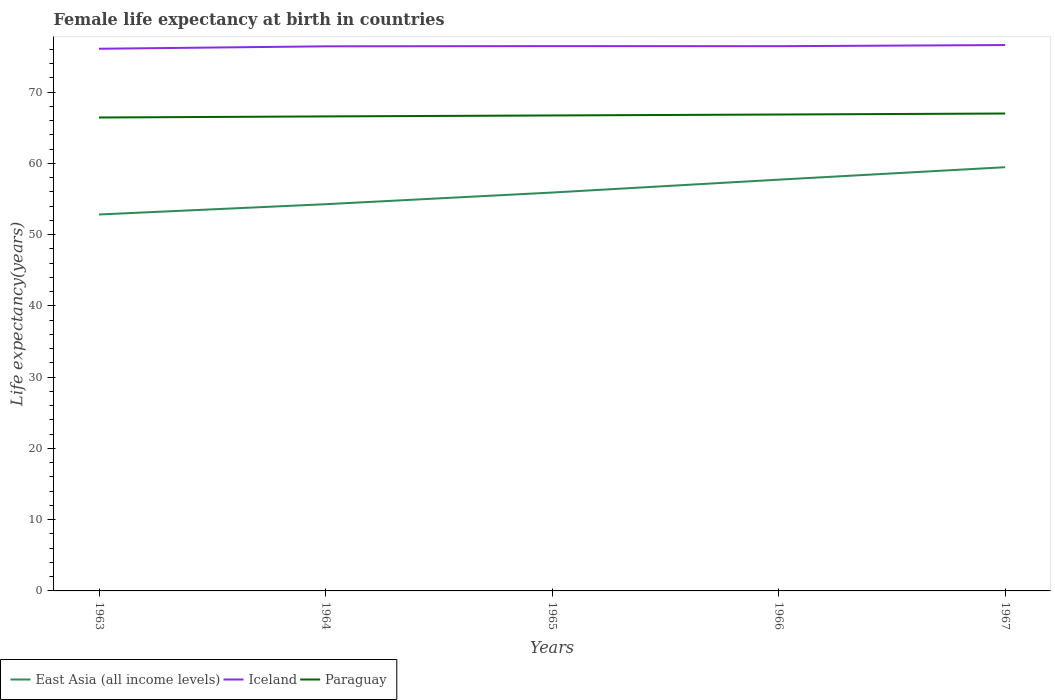How many different coloured lines are there?
Your answer should be compact. 3. Does the line corresponding to Paraguay intersect with the line corresponding to East Asia (all income levels)?
Offer a terse response. No. Is the number of lines equal to the number of legend labels?
Provide a short and direct response. Yes. Across all years, what is the maximum female life expectancy at birth in Iceland?
Offer a very short reply. 76.07. In which year was the female life expectancy at birth in East Asia (all income levels) maximum?
Keep it short and to the point. 1963. What is the total female life expectancy at birth in Paraguay in the graph?
Your answer should be compact. -0.14. What is the difference between the highest and the second highest female life expectancy at birth in East Asia (all income levels)?
Provide a short and direct response. 6.63. Is the female life expectancy at birth in Paraguay strictly greater than the female life expectancy at birth in East Asia (all income levels) over the years?
Offer a very short reply. No. Are the values on the major ticks of Y-axis written in scientific E-notation?
Your answer should be very brief. No. Does the graph contain any zero values?
Provide a short and direct response. No. Does the graph contain grids?
Provide a short and direct response. No. How are the legend labels stacked?
Offer a very short reply. Horizontal. What is the title of the graph?
Offer a very short reply. Female life expectancy at birth in countries. What is the label or title of the Y-axis?
Provide a short and direct response. Life expectancy(years). What is the Life expectancy(years) in East Asia (all income levels) in 1963?
Your answer should be very brief. 52.82. What is the Life expectancy(years) in Iceland in 1963?
Offer a very short reply. 76.07. What is the Life expectancy(years) of Paraguay in 1963?
Keep it short and to the point. 66.42. What is the Life expectancy(years) in East Asia (all income levels) in 1964?
Provide a succinct answer. 54.26. What is the Life expectancy(years) in Iceland in 1964?
Provide a succinct answer. 76.41. What is the Life expectancy(years) of Paraguay in 1964?
Offer a very short reply. 66.58. What is the Life expectancy(years) in East Asia (all income levels) in 1965?
Ensure brevity in your answer.  55.89. What is the Life expectancy(years) in Iceland in 1965?
Your answer should be compact. 76.44. What is the Life expectancy(years) in Paraguay in 1965?
Offer a very short reply. 66.71. What is the Life expectancy(years) of East Asia (all income levels) in 1966?
Keep it short and to the point. 57.7. What is the Life expectancy(years) in Iceland in 1966?
Ensure brevity in your answer.  76.43. What is the Life expectancy(years) of Paraguay in 1966?
Your response must be concise. 66.84. What is the Life expectancy(years) of East Asia (all income levels) in 1967?
Provide a short and direct response. 59.45. What is the Life expectancy(years) of Iceland in 1967?
Give a very brief answer. 76.59. What is the Life expectancy(years) of Paraguay in 1967?
Ensure brevity in your answer.  66.98. Across all years, what is the maximum Life expectancy(years) in East Asia (all income levels)?
Give a very brief answer. 59.45. Across all years, what is the maximum Life expectancy(years) in Iceland?
Ensure brevity in your answer.  76.59. Across all years, what is the maximum Life expectancy(years) of Paraguay?
Your answer should be very brief. 66.98. Across all years, what is the minimum Life expectancy(years) in East Asia (all income levels)?
Make the answer very short. 52.82. Across all years, what is the minimum Life expectancy(years) in Iceland?
Provide a succinct answer. 76.07. Across all years, what is the minimum Life expectancy(years) in Paraguay?
Ensure brevity in your answer.  66.42. What is the total Life expectancy(years) in East Asia (all income levels) in the graph?
Your answer should be very brief. 280.12. What is the total Life expectancy(years) in Iceland in the graph?
Make the answer very short. 381.94. What is the total Life expectancy(years) of Paraguay in the graph?
Give a very brief answer. 333.54. What is the difference between the Life expectancy(years) of East Asia (all income levels) in 1963 and that in 1964?
Your answer should be compact. -1.44. What is the difference between the Life expectancy(years) of Iceland in 1963 and that in 1964?
Your response must be concise. -0.34. What is the difference between the Life expectancy(years) in Paraguay in 1963 and that in 1964?
Your answer should be very brief. -0.15. What is the difference between the Life expectancy(years) in East Asia (all income levels) in 1963 and that in 1965?
Provide a short and direct response. -3.08. What is the difference between the Life expectancy(years) of Iceland in 1963 and that in 1965?
Ensure brevity in your answer.  -0.37. What is the difference between the Life expectancy(years) of Paraguay in 1963 and that in 1965?
Offer a terse response. -0.29. What is the difference between the Life expectancy(years) of East Asia (all income levels) in 1963 and that in 1966?
Your answer should be very brief. -4.89. What is the difference between the Life expectancy(years) in Iceland in 1963 and that in 1966?
Make the answer very short. -0.36. What is the difference between the Life expectancy(years) of Paraguay in 1963 and that in 1966?
Give a very brief answer. -0.42. What is the difference between the Life expectancy(years) in East Asia (all income levels) in 1963 and that in 1967?
Make the answer very short. -6.63. What is the difference between the Life expectancy(years) in Iceland in 1963 and that in 1967?
Your answer should be compact. -0.52. What is the difference between the Life expectancy(years) of Paraguay in 1963 and that in 1967?
Give a very brief answer. -0.56. What is the difference between the Life expectancy(years) in East Asia (all income levels) in 1964 and that in 1965?
Provide a short and direct response. -1.64. What is the difference between the Life expectancy(years) in Iceland in 1964 and that in 1965?
Make the answer very short. -0.03. What is the difference between the Life expectancy(years) of Paraguay in 1964 and that in 1965?
Offer a terse response. -0.13. What is the difference between the Life expectancy(years) in East Asia (all income levels) in 1964 and that in 1966?
Offer a very short reply. -3.44. What is the difference between the Life expectancy(years) in Iceland in 1964 and that in 1966?
Your answer should be compact. -0.02. What is the difference between the Life expectancy(years) of Paraguay in 1964 and that in 1966?
Keep it short and to the point. -0.27. What is the difference between the Life expectancy(years) of East Asia (all income levels) in 1964 and that in 1967?
Provide a succinct answer. -5.19. What is the difference between the Life expectancy(years) in Iceland in 1964 and that in 1967?
Your answer should be very brief. -0.18. What is the difference between the Life expectancy(years) of Paraguay in 1964 and that in 1967?
Your answer should be compact. -0.41. What is the difference between the Life expectancy(years) in East Asia (all income levels) in 1965 and that in 1966?
Keep it short and to the point. -1.81. What is the difference between the Life expectancy(years) of Iceland in 1965 and that in 1966?
Offer a very short reply. 0.01. What is the difference between the Life expectancy(years) in Paraguay in 1965 and that in 1966?
Offer a very short reply. -0.13. What is the difference between the Life expectancy(years) of East Asia (all income levels) in 1965 and that in 1967?
Ensure brevity in your answer.  -3.56. What is the difference between the Life expectancy(years) of Paraguay in 1965 and that in 1967?
Offer a very short reply. -0.27. What is the difference between the Life expectancy(years) of East Asia (all income levels) in 1966 and that in 1967?
Offer a terse response. -1.75. What is the difference between the Life expectancy(years) of Iceland in 1966 and that in 1967?
Ensure brevity in your answer.  -0.16. What is the difference between the Life expectancy(years) of Paraguay in 1966 and that in 1967?
Your answer should be compact. -0.14. What is the difference between the Life expectancy(years) of East Asia (all income levels) in 1963 and the Life expectancy(years) of Iceland in 1964?
Your response must be concise. -23.59. What is the difference between the Life expectancy(years) in East Asia (all income levels) in 1963 and the Life expectancy(years) in Paraguay in 1964?
Offer a very short reply. -13.76. What is the difference between the Life expectancy(years) in Iceland in 1963 and the Life expectancy(years) in Paraguay in 1964?
Give a very brief answer. 9.49. What is the difference between the Life expectancy(years) in East Asia (all income levels) in 1963 and the Life expectancy(years) in Iceland in 1965?
Keep it short and to the point. -23.62. What is the difference between the Life expectancy(years) of East Asia (all income levels) in 1963 and the Life expectancy(years) of Paraguay in 1965?
Ensure brevity in your answer.  -13.89. What is the difference between the Life expectancy(years) of Iceland in 1963 and the Life expectancy(years) of Paraguay in 1965?
Your answer should be compact. 9.36. What is the difference between the Life expectancy(years) of East Asia (all income levels) in 1963 and the Life expectancy(years) of Iceland in 1966?
Give a very brief answer. -23.61. What is the difference between the Life expectancy(years) of East Asia (all income levels) in 1963 and the Life expectancy(years) of Paraguay in 1966?
Offer a terse response. -14.03. What is the difference between the Life expectancy(years) in Iceland in 1963 and the Life expectancy(years) in Paraguay in 1966?
Your answer should be compact. 9.23. What is the difference between the Life expectancy(years) in East Asia (all income levels) in 1963 and the Life expectancy(years) in Iceland in 1967?
Your answer should be very brief. -23.77. What is the difference between the Life expectancy(years) of East Asia (all income levels) in 1963 and the Life expectancy(years) of Paraguay in 1967?
Your response must be concise. -14.17. What is the difference between the Life expectancy(years) of Iceland in 1963 and the Life expectancy(years) of Paraguay in 1967?
Make the answer very short. 9.09. What is the difference between the Life expectancy(years) in East Asia (all income levels) in 1964 and the Life expectancy(years) in Iceland in 1965?
Give a very brief answer. -22.18. What is the difference between the Life expectancy(years) in East Asia (all income levels) in 1964 and the Life expectancy(years) in Paraguay in 1965?
Offer a terse response. -12.45. What is the difference between the Life expectancy(years) in Iceland in 1964 and the Life expectancy(years) in Paraguay in 1965?
Provide a short and direct response. 9.7. What is the difference between the Life expectancy(years) in East Asia (all income levels) in 1964 and the Life expectancy(years) in Iceland in 1966?
Ensure brevity in your answer.  -22.17. What is the difference between the Life expectancy(years) of East Asia (all income levels) in 1964 and the Life expectancy(years) of Paraguay in 1966?
Offer a terse response. -12.58. What is the difference between the Life expectancy(years) of Iceland in 1964 and the Life expectancy(years) of Paraguay in 1966?
Give a very brief answer. 9.57. What is the difference between the Life expectancy(years) of East Asia (all income levels) in 1964 and the Life expectancy(years) of Iceland in 1967?
Your answer should be compact. -22.33. What is the difference between the Life expectancy(years) of East Asia (all income levels) in 1964 and the Life expectancy(years) of Paraguay in 1967?
Provide a short and direct response. -12.73. What is the difference between the Life expectancy(years) of Iceland in 1964 and the Life expectancy(years) of Paraguay in 1967?
Your answer should be very brief. 9.43. What is the difference between the Life expectancy(years) of East Asia (all income levels) in 1965 and the Life expectancy(years) of Iceland in 1966?
Offer a very short reply. -20.54. What is the difference between the Life expectancy(years) in East Asia (all income levels) in 1965 and the Life expectancy(years) in Paraguay in 1966?
Provide a succinct answer. -10.95. What is the difference between the Life expectancy(years) in Iceland in 1965 and the Life expectancy(years) in Paraguay in 1966?
Provide a succinct answer. 9.6. What is the difference between the Life expectancy(years) in East Asia (all income levels) in 1965 and the Life expectancy(years) in Iceland in 1967?
Give a very brief answer. -20.7. What is the difference between the Life expectancy(years) of East Asia (all income levels) in 1965 and the Life expectancy(years) of Paraguay in 1967?
Keep it short and to the point. -11.09. What is the difference between the Life expectancy(years) of Iceland in 1965 and the Life expectancy(years) of Paraguay in 1967?
Provide a succinct answer. 9.46. What is the difference between the Life expectancy(years) of East Asia (all income levels) in 1966 and the Life expectancy(years) of Iceland in 1967?
Provide a short and direct response. -18.89. What is the difference between the Life expectancy(years) in East Asia (all income levels) in 1966 and the Life expectancy(years) in Paraguay in 1967?
Provide a short and direct response. -9.28. What is the difference between the Life expectancy(years) in Iceland in 1966 and the Life expectancy(years) in Paraguay in 1967?
Offer a very short reply. 9.45. What is the average Life expectancy(years) of East Asia (all income levels) per year?
Your answer should be compact. 56.02. What is the average Life expectancy(years) in Iceland per year?
Make the answer very short. 76.39. What is the average Life expectancy(years) in Paraguay per year?
Your answer should be very brief. 66.71. In the year 1963, what is the difference between the Life expectancy(years) of East Asia (all income levels) and Life expectancy(years) of Iceland?
Provide a succinct answer. -23.25. In the year 1963, what is the difference between the Life expectancy(years) of East Asia (all income levels) and Life expectancy(years) of Paraguay?
Provide a succinct answer. -13.61. In the year 1963, what is the difference between the Life expectancy(years) of Iceland and Life expectancy(years) of Paraguay?
Ensure brevity in your answer.  9.64. In the year 1964, what is the difference between the Life expectancy(years) of East Asia (all income levels) and Life expectancy(years) of Iceland?
Give a very brief answer. -22.15. In the year 1964, what is the difference between the Life expectancy(years) in East Asia (all income levels) and Life expectancy(years) in Paraguay?
Give a very brief answer. -12.32. In the year 1964, what is the difference between the Life expectancy(years) in Iceland and Life expectancy(years) in Paraguay?
Provide a short and direct response. 9.83. In the year 1965, what is the difference between the Life expectancy(years) of East Asia (all income levels) and Life expectancy(years) of Iceland?
Ensure brevity in your answer.  -20.55. In the year 1965, what is the difference between the Life expectancy(years) of East Asia (all income levels) and Life expectancy(years) of Paraguay?
Provide a succinct answer. -10.82. In the year 1965, what is the difference between the Life expectancy(years) of Iceland and Life expectancy(years) of Paraguay?
Keep it short and to the point. 9.73. In the year 1966, what is the difference between the Life expectancy(years) of East Asia (all income levels) and Life expectancy(years) of Iceland?
Provide a short and direct response. -18.73. In the year 1966, what is the difference between the Life expectancy(years) of East Asia (all income levels) and Life expectancy(years) of Paraguay?
Your answer should be compact. -9.14. In the year 1966, what is the difference between the Life expectancy(years) of Iceland and Life expectancy(years) of Paraguay?
Keep it short and to the point. 9.59. In the year 1967, what is the difference between the Life expectancy(years) in East Asia (all income levels) and Life expectancy(years) in Iceland?
Give a very brief answer. -17.14. In the year 1967, what is the difference between the Life expectancy(years) in East Asia (all income levels) and Life expectancy(years) in Paraguay?
Offer a very short reply. -7.53. In the year 1967, what is the difference between the Life expectancy(years) in Iceland and Life expectancy(years) in Paraguay?
Give a very brief answer. 9.61. What is the ratio of the Life expectancy(years) in East Asia (all income levels) in 1963 to that in 1964?
Offer a very short reply. 0.97. What is the ratio of the Life expectancy(years) of East Asia (all income levels) in 1963 to that in 1965?
Give a very brief answer. 0.94. What is the ratio of the Life expectancy(years) of East Asia (all income levels) in 1963 to that in 1966?
Make the answer very short. 0.92. What is the ratio of the Life expectancy(years) of Iceland in 1963 to that in 1966?
Give a very brief answer. 1. What is the ratio of the Life expectancy(years) in Paraguay in 1963 to that in 1966?
Provide a short and direct response. 0.99. What is the ratio of the Life expectancy(years) of East Asia (all income levels) in 1963 to that in 1967?
Offer a very short reply. 0.89. What is the ratio of the Life expectancy(years) in East Asia (all income levels) in 1964 to that in 1965?
Ensure brevity in your answer.  0.97. What is the ratio of the Life expectancy(years) in Iceland in 1964 to that in 1965?
Provide a succinct answer. 1. What is the ratio of the Life expectancy(years) in Paraguay in 1964 to that in 1965?
Ensure brevity in your answer.  1. What is the ratio of the Life expectancy(years) in East Asia (all income levels) in 1964 to that in 1966?
Offer a terse response. 0.94. What is the ratio of the Life expectancy(years) of Iceland in 1964 to that in 1966?
Give a very brief answer. 1. What is the ratio of the Life expectancy(years) in Paraguay in 1964 to that in 1966?
Provide a short and direct response. 1. What is the ratio of the Life expectancy(years) in East Asia (all income levels) in 1964 to that in 1967?
Provide a short and direct response. 0.91. What is the ratio of the Life expectancy(years) of Paraguay in 1964 to that in 1967?
Provide a short and direct response. 0.99. What is the ratio of the Life expectancy(years) of East Asia (all income levels) in 1965 to that in 1966?
Provide a succinct answer. 0.97. What is the ratio of the Life expectancy(years) of Iceland in 1965 to that in 1966?
Your response must be concise. 1. What is the ratio of the Life expectancy(years) in Paraguay in 1965 to that in 1966?
Keep it short and to the point. 1. What is the ratio of the Life expectancy(years) in East Asia (all income levels) in 1965 to that in 1967?
Your answer should be very brief. 0.94. What is the ratio of the Life expectancy(years) of Iceland in 1965 to that in 1967?
Provide a short and direct response. 1. What is the ratio of the Life expectancy(years) in East Asia (all income levels) in 1966 to that in 1967?
Offer a very short reply. 0.97. What is the ratio of the Life expectancy(years) of Iceland in 1966 to that in 1967?
Make the answer very short. 1. What is the difference between the highest and the second highest Life expectancy(years) in East Asia (all income levels)?
Make the answer very short. 1.75. What is the difference between the highest and the second highest Life expectancy(years) of Iceland?
Offer a very short reply. 0.15. What is the difference between the highest and the second highest Life expectancy(years) in Paraguay?
Your answer should be compact. 0.14. What is the difference between the highest and the lowest Life expectancy(years) in East Asia (all income levels)?
Make the answer very short. 6.63. What is the difference between the highest and the lowest Life expectancy(years) in Iceland?
Your response must be concise. 0.52. What is the difference between the highest and the lowest Life expectancy(years) in Paraguay?
Provide a succinct answer. 0.56. 